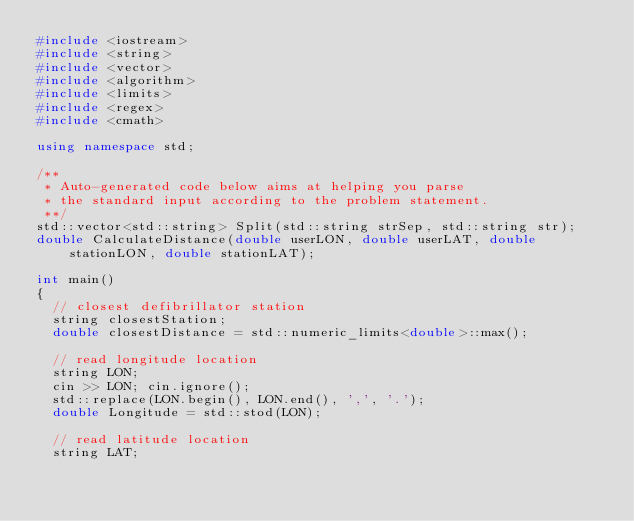Convert code to text. <code><loc_0><loc_0><loc_500><loc_500><_C++_>#include <iostream>
#include <string>
#include <vector>
#include <algorithm>
#include <limits>
#include <regex>
#include <cmath>

using namespace std;

/**
 * Auto-generated code below aims at helping you parse
 * the standard input according to the problem statement.
 **/
std::vector<std::string> Split(std::string strSep, std::string str);
double CalculateDistance(double userLON, double userLAT, double stationLON, double stationLAT);

int main()
{
	// closest defibrillator station
	string closestStation;
	double closestDistance = std::numeric_limits<double>::max();

	// read longitude location
	string LON;
	cin >> LON; cin.ignore();
	std::replace(LON.begin(), LON.end(), ',', '.');
	double Longitude = std::stod(LON);

	// read latitude location
	string LAT;</code> 